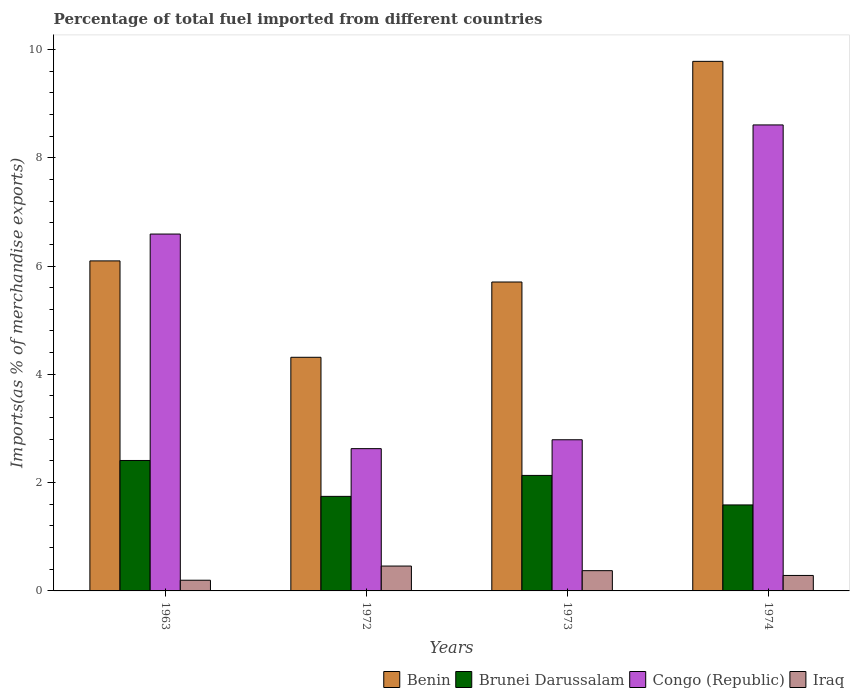How many bars are there on the 2nd tick from the left?
Ensure brevity in your answer.  4. What is the label of the 1st group of bars from the left?
Your response must be concise. 1963. What is the percentage of imports to different countries in Iraq in 1972?
Your response must be concise. 0.46. Across all years, what is the maximum percentage of imports to different countries in Brunei Darussalam?
Make the answer very short. 2.41. Across all years, what is the minimum percentage of imports to different countries in Iraq?
Give a very brief answer. 0.2. In which year was the percentage of imports to different countries in Iraq maximum?
Your answer should be compact. 1972. What is the total percentage of imports to different countries in Benin in the graph?
Give a very brief answer. 25.89. What is the difference between the percentage of imports to different countries in Iraq in 1963 and that in 1972?
Provide a succinct answer. -0.26. What is the difference between the percentage of imports to different countries in Iraq in 1963 and the percentage of imports to different countries in Benin in 1972?
Your response must be concise. -4.12. What is the average percentage of imports to different countries in Iraq per year?
Provide a succinct answer. 0.33. In the year 1963, what is the difference between the percentage of imports to different countries in Brunei Darussalam and percentage of imports to different countries in Iraq?
Give a very brief answer. 2.21. What is the ratio of the percentage of imports to different countries in Brunei Darussalam in 1963 to that in 1974?
Offer a very short reply. 1.52. What is the difference between the highest and the second highest percentage of imports to different countries in Brunei Darussalam?
Make the answer very short. 0.28. What is the difference between the highest and the lowest percentage of imports to different countries in Congo (Republic)?
Your answer should be very brief. 5.98. In how many years, is the percentage of imports to different countries in Iraq greater than the average percentage of imports to different countries in Iraq taken over all years?
Provide a succinct answer. 2. Is the sum of the percentage of imports to different countries in Congo (Republic) in 1963 and 1974 greater than the maximum percentage of imports to different countries in Brunei Darussalam across all years?
Ensure brevity in your answer.  Yes. What does the 3rd bar from the left in 1963 represents?
Your answer should be very brief. Congo (Republic). What does the 2nd bar from the right in 1963 represents?
Provide a succinct answer. Congo (Republic). How many bars are there?
Ensure brevity in your answer.  16. How many years are there in the graph?
Your answer should be compact. 4. Are the values on the major ticks of Y-axis written in scientific E-notation?
Provide a short and direct response. No. Does the graph contain any zero values?
Keep it short and to the point. No. Where does the legend appear in the graph?
Your response must be concise. Bottom right. How are the legend labels stacked?
Provide a succinct answer. Horizontal. What is the title of the graph?
Provide a succinct answer. Percentage of total fuel imported from different countries. Does "Barbados" appear as one of the legend labels in the graph?
Provide a short and direct response. No. What is the label or title of the Y-axis?
Make the answer very short. Imports(as % of merchandise exports). What is the Imports(as % of merchandise exports) in Benin in 1963?
Provide a succinct answer. 6.09. What is the Imports(as % of merchandise exports) of Brunei Darussalam in 1963?
Give a very brief answer. 2.41. What is the Imports(as % of merchandise exports) of Congo (Republic) in 1963?
Keep it short and to the point. 6.59. What is the Imports(as % of merchandise exports) in Iraq in 1963?
Ensure brevity in your answer.  0.2. What is the Imports(as % of merchandise exports) in Benin in 1972?
Offer a terse response. 4.31. What is the Imports(as % of merchandise exports) in Brunei Darussalam in 1972?
Ensure brevity in your answer.  1.75. What is the Imports(as % of merchandise exports) of Congo (Republic) in 1972?
Keep it short and to the point. 2.63. What is the Imports(as % of merchandise exports) in Iraq in 1972?
Your answer should be very brief. 0.46. What is the Imports(as % of merchandise exports) of Benin in 1973?
Your answer should be very brief. 5.7. What is the Imports(as % of merchandise exports) of Brunei Darussalam in 1973?
Your answer should be very brief. 2.13. What is the Imports(as % of merchandise exports) in Congo (Republic) in 1973?
Make the answer very short. 2.79. What is the Imports(as % of merchandise exports) in Iraq in 1973?
Offer a terse response. 0.37. What is the Imports(as % of merchandise exports) of Benin in 1974?
Give a very brief answer. 9.78. What is the Imports(as % of merchandise exports) of Brunei Darussalam in 1974?
Offer a terse response. 1.59. What is the Imports(as % of merchandise exports) of Congo (Republic) in 1974?
Your response must be concise. 8.61. What is the Imports(as % of merchandise exports) of Iraq in 1974?
Your answer should be very brief. 0.29. Across all years, what is the maximum Imports(as % of merchandise exports) of Benin?
Your answer should be compact. 9.78. Across all years, what is the maximum Imports(as % of merchandise exports) in Brunei Darussalam?
Your response must be concise. 2.41. Across all years, what is the maximum Imports(as % of merchandise exports) of Congo (Republic)?
Your answer should be compact. 8.61. Across all years, what is the maximum Imports(as % of merchandise exports) in Iraq?
Give a very brief answer. 0.46. Across all years, what is the minimum Imports(as % of merchandise exports) of Benin?
Your answer should be compact. 4.31. Across all years, what is the minimum Imports(as % of merchandise exports) of Brunei Darussalam?
Offer a terse response. 1.59. Across all years, what is the minimum Imports(as % of merchandise exports) in Congo (Republic)?
Your response must be concise. 2.63. Across all years, what is the minimum Imports(as % of merchandise exports) of Iraq?
Keep it short and to the point. 0.2. What is the total Imports(as % of merchandise exports) in Benin in the graph?
Your answer should be very brief. 25.89. What is the total Imports(as % of merchandise exports) of Brunei Darussalam in the graph?
Keep it short and to the point. 7.88. What is the total Imports(as % of merchandise exports) in Congo (Republic) in the graph?
Your response must be concise. 20.61. What is the total Imports(as % of merchandise exports) of Iraq in the graph?
Give a very brief answer. 1.32. What is the difference between the Imports(as % of merchandise exports) of Benin in 1963 and that in 1972?
Provide a succinct answer. 1.78. What is the difference between the Imports(as % of merchandise exports) in Brunei Darussalam in 1963 and that in 1972?
Give a very brief answer. 0.66. What is the difference between the Imports(as % of merchandise exports) in Congo (Republic) in 1963 and that in 1972?
Your response must be concise. 3.96. What is the difference between the Imports(as % of merchandise exports) in Iraq in 1963 and that in 1972?
Your response must be concise. -0.26. What is the difference between the Imports(as % of merchandise exports) in Benin in 1963 and that in 1973?
Ensure brevity in your answer.  0.39. What is the difference between the Imports(as % of merchandise exports) in Brunei Darussalam in 1963 and that in 1973?
Your response must be concise. 0.28. What is the difference between the Imports(as % of merchandise exports) in Congo (Republic) in 1963 and that in 1973?
Offer a very short reply. 3.8. What is the difference between the Imports(as % of merchandise exports) in Iraq in 1963 and that in 1973?
Keep it short and to the point. -0.18. What is the difference between the Imports(as % of merchandise exports) in Benin in 1963 and that in 1974?
Offer a terse response. -3.68. What is the difference between the Imports(as % of merchandise exports) of Brunei Darussalam in 1963 and that in 1974?
Provide a short and direct response. 0.82. What is the difference between the Imports(as % of merchandise exports) in Congo (Republic) in 1963 and that in 1974?
Your response must be concise. -2.02. What is the difference between the Imports(as % of merchandise exports) in Iraq in 1963 and that in 1974?
Make the answer very short. -0.09. What is the difference between the Imports(as % of merchandise exports) in Benin in 1972 and that in 1973?
Ensure brevity in your answer.  -1.39. What is the difference between the Imports(as % of merchandise exports) of Brunei Darussalam in 1972 and that in 1973?
Keep it short and to the point. -0.39. What is the difference between the Imports(as % of merchandise exports) in Congo (Republic) in 1972 and that in 1973?
Provide a short and direct response. -0.16. What is the difference between the Imports(as % of merchandise exports) of Iraq in 1972 and that in 1973?
Your answer should be very brief. 0.09. What is the difference between the Imports(as % of merchandise exports) of Benin in 1972 and that in 1974?
Provide a short and direct response. -5.46. What is the difference between the Imports(as % of merchandise exports) of Brunei Darussalam in 1972 and that in 1974?
Offer a terse response. 0.16. What is the difference between the Imports(as % of merchandise exports) of Congo (Republic) in 1972 and that in 1974?
Provide a succinct answer. -5.98. What is the difference between the Imports(as % of merchandise exports) of Iraq in 1972 and that in 1974?
Make the answer very short. 0.17. What is the difference between the Imports(as % of merchandise exports) of Benin in 1973 and that in 1974?
Your response must be concise. -4.07. What is the difference between the Imports(as % of merchandise exports) of Brunei Darussalam in 1973 and that in 1974?
Provide a succinct answer. 0.55. What is the difference between the Imports(as % of merchandise exports) in Congo (Republic) in 1973 and that in 1974?
Give a very brief answer. -5.81. What is the difference between the Imports(as % of merchandise exports) in Iraq in 1973 and that in 1974?
Offer a very short reply. 0.09. What is the difference between the Imports(as % of merchandise exports) of Benin in 1963 and the Imports(as % of merchandise exports) of Brunei Darussalam in 1972?
Make the answer very short. 4.35. What is the difference between the Imports(as % of merchandise exports) of Benin in 1963 and the Imports(as % of merchandise exports) of Congo (Republic) in 1972?
Provide a succinct answer. 3.47. What is the difference between the Imports(as % of merchandise exports) in Benin in 1963 and the Imports(as % of merchandise exports) in Iraq in 1972?
Ensure brevity in your answer.  5.63. What is the difference between the Imports(as % of merchandise exports) in Brunei Darussalam in 1963 and the Imports(as % of merchandise exports) in Congo (Republic) in 1972?
Offer a terse response. -0.22. What is the difference between the Imports(as % of merchandise exports) of Brunei Darussalam in 1963 and the Imports(as % of merchandise exports) of Iraq in 1972?
Provide a succinct answer. 1.95. What is the difference between the Imports(as % of merchandise exports) in Congo (Republic) in 1963 and the Imports(as % of merchandise exports) in Iraq in 1972?
Give a very brief answer. 6.13. What is the difference between the Imports(as % of merchandise exports) in Benin in 1963 and the Imports(as % of merchandise exports) in Brunei Darussalam in 1973?
Offer a terse response. 3.96. What is the difference between the Imports(as % of merchandise exports) in Benin in 1963 and the Imports(as % of merchandise exports) in Congo (Republic) in 1973?
Keep it short and to the point. 3.3. What is the difference between the Imports(as % of merchandise exports) in Benin in 1963 and the Imports(as % of merchandise exports) in Iraq in 1973?
Give a very brief answer. 5.72. What is the difference between the Imports(as % of merchandise exports) of Brunei Darussalam in 1963 and the Imports(as % of merchandise exports) of Congo (Republic) in 1973?
Your answer should be very brief. -0.38. What is the difference between the Imports(as % of merchandise exports) of Brunei Darussalam in 1963 and the Imports(as % of merchandise exports) of Iraq in 1973?
Your answer should be very brief. 2.03. What is the difference between the Imports(as % of merchandise exports) of Congo (Republic) in 1963 and the Imports(as % of merchandise exports) of Iraq in 1973?
Your answer should be very brief. 6.22. What is the difference between the Imports(as % of merchandise exports) in Benin in 1963 and the Imports(as % of merchandise exports) in Brunei Darussalam in 1974?
Give a very brief answer. 4.51. What is the difference between the Imports(as % of merchandise exports) of Benin in 1963 and the Imports(as % of merchandise exports) of Congo (Republic) in 1974?
Ensure brevity in your answer.  -2.51. What is the difference between the Imports(as % of merchandise exports) in Benin in 1963 and the Imports(as % of merchandise exports) in Iraq in 1974?
Give a very brief answer. 5.81. What is the difference between the Imports(as % of merchandise exports) in Brunei Darussalam in 1963 and the Imports(as % of merchandise exports) in Congo (Republic) in 1974?
Your answer should be compact. -6.2. What is the difference between the Imports(as % of merchandise exports) of Brunei Darussalam in 1963 and the Imports(as % of merchandise exports) of Iraq in 1974?
Offer a terse response. 2.12. What is the difference between the Imports(as % of merchandise exports) in Congo (Republic) in 1963 and the Imports(as % of merchandise exports) in Iraq in 1974?
Make the answer very short. 6.3. What is the difference between the Imports(as % of merchandise exports) in Benin in 1972 and the Imports(as % of merchandise exports) in Brunei Darussalam in 1973?
Provide a short and direct response. 2.18. What is the difference between the Imports(as % of merchandise exports) in Benin in 1972 and the Imports(as % of merchandise exports) in Congo (Republic) in 1973?
Ensure brevity in your answer.  1.52. What is the difference between the Imports(as % of merchandise exports) of Benin in 1972 and the Imports(as % of merchandise exports) of Iraq in 1973?
Offer a terse response. 3.94. What is the difference between the Imports(as % of merchandise exports) of Brunei Darussalam in 1972 and the Imports(as % of merchandise exports) of Congo (Republic) in 1973?
Give a very brief answer. -1.05. What is the difference between the Imports(as % of merchandise exports) of Brunei Darussalam in 1972 and the Imports(as % of merchandise exports) of Iraq in 1973?
Offer a very short reply. 1.37. What is the difference between the Imports(as % of merchandise exports) in Congo (Republic) in 1972 and the Imports(as % of merchandise exports) in Iraq in 1973?
Provide a short and direct response. 2.25. What is the difference between the Imports(as % of merchandise exports) of Benin in 1972 and the Imports(as % of merchandise exports) of Brunei Darussalam in 1974?
Keep it short and to the point. 2.73. What is the difference between the Imports(as % of merchandise exports) in Benin in 1972 and the Imports(as % of merchandise exports) in Congo (Republic) in 1974?
Your answer should be very brief. -4.29. What is the difference between the Imports(as % of merchandise exports) of Benin in 1972 and the Imports(as % of merchandise exports) of Iraq in 1974?
Provide a short and direct response. 4.03. What is the difference between the Imports(as % of merchandise exports) in Brunei Darussalam in 1972 and the Imports(as % of merchandise exports) in Congo (Republic) in 1974?
Offer a very short reply. -6.86. What is the difference between the Imports(as % of merchandise exports) in Brunei Darussalam in 1972 and the Imports(as % of merchandise exports) in Iraq in 1974?
Make the answer very short. 1.46. What is the difference between the Imports(as % of merchandise exports) of Congo (Republic) in 1972 and the Imports(as % of merchandise exports) of Iraq in 1974?
Give a very brief answer. 2.34. What is the difference between the Imports(as % of merchandise exports) of Benin in 1973 and the Imports(as % of merchandise exports) of Brunei Darussalam in 1974?
Offer a terse response. 4.12. What is the difference between the Imports(as % of merchandise exports) in Benin in 1973 and the Imports(as % of merchandise exports) in Congo (Republic) in 1974?
Offer a very short reply. -2.9. What is the difference between the Imports(as % of merchandise exports) of Benin in 1973 and the Imports(as % of merchandise exports) of Iraq in 1974?
Give a very brief answer. 5.42. What is the difference between the Imports(as % of merchandise exports) in Brunei Darussalam in 1973 and the Imports(as % of merchandise exports) in Congo (Republic) in 1974?
Ensure brevity in your answer.  -6.47. What is the difference between the Imports(as % of merchandise exports) in Brunei Darussalam in 1973 and the Imports(as % of merchandise exports) in Iraq in 1974?
Ensure brevity in your answer.  1.85. What is the difference between the Imports(as % of merchandise exports) in Congo (Republic) in 1973 and the Imports(as % of merchandise exports) in Iraq in 1974?
Offer a terse response. 2.51. What is the average Imports(as % of merchandise exports) in Benin per year?
Ensure brevity in your answer.  6.47. What is the average Imports(as % of merchandise exports) in Brunei Darussalam per year?
Your answer should be very brief. 1.97. What is the average Imports(as % of merchandise exports) in Congo (Republic) per year?
Keep it short and to the point. 5.15. What is the average Imports(as % of merchandise exports) of Iraq per year?
Ensure brevity in your answer.  0.33. In the year 1963, what is the difference between the Imports(as % of merchandise exports) of Benin and Imports(as % of merchandise exports) of Brunei Darussalam?
Your response must be concise. 3.69. In the year 1963, what is the difference between the Imports(as % of merchandise exports) in Benin and Imports(as % of merchandise exports) in Congo (Republic)?
Make the answer very short. -0.5. In the year 1963, what is the difference between the Imports(as % of merchandise exports) of Benin and Imports(as % of merchandise exports) of Iraq?
Make the answer very short. 5.9. In the year 1963, what is the difference between the Imports(as % of merchandise exports) in Brunei Darussalam and Imports(as % of merchandise exports) in Congo (Republic)?
Offer a terse response. -4.18. In the year 1963, what is the difference between the Imports(as % of merchandise exports) in Brunei Darussalam and Imports(as % of merchandise exports) in Iraq?
Provide a short and direct response. 2.21. In the year 1963, what is the difference between the Imports(as % of merchandise exports) in Congo (Republic) and Imports(as % of merchandise exports) in Iraq?
Provide a short and direct response. 6.39. In the year 1972, what is the difference between the Imports(as % of merchandise exports) in Benin and Imports(as % of merchandise exports) in Brunei Darussalam?
Ensure brevity in your answer.  2.57. In the year 1972, what is the difference between the Imports(as % of merchandise exports) of Benin and Imports(as % of merchandise exports) of Congo (Republic)?
Your answer should be compact. 1.69. In the year 1972, what is the difference between the Imports(as % of merchandise exports) in Benin and Imports(as % of merchandise exports) in Iraq?
Your response must be concise. 3.85. In the year 1972, what is the difference between the Imports(as % of merchandise exports) in Brunei Darussalam and Imports(as % of merchandise exports) in Congo (Republic)?
Offer a terse response. -0.88. In the year 1972, what is the difference between the Imports(as % of merchandise exports) of Brunei Darussalam and Imports(as % of merchandise exports) of Iraq?
Provide a short and direct response. 1.29. In the year 1972, what is the difference between the Imports(as % of merchandise exports) in Congo (Republic) and Imports(as % of merchandise exports) in Iraq?
Give a very brief answer. 2.17. In the year 1973, what is the difference between the Imports(as % of merchandise exports) of Benin and Imports(as % of merchandise exports) of Brunei Darussalam?
Your answer should be very brief. 3.57. In the year 1973, what is the difference between the Imports(as % of merchandise exports) in Benin and Imports(as % of merchandise exports) in Congo (Republic)?
Keep it short and to the point. 2.91. In the year 1973, what is the difference between the Imports(as % of merchandise exports) in Benin and Imports(as % of merchandise exports) in Iraq?
Your answer should be very brief. 5.33. In the year 1973, what is the difference between the Imports(as % of merchandise exports) in Brunei Darussalam and Imports(as % of merchandise exports) in Congo (Republic)?
Give a very brief answer. -0.66. In the year 1973, what is the difference between the Imports(as % of merchandise exports) in Brunei Darussalam and Imports(as % of merchandise exports) in Iraq?
Keep it short and to the point. 1.76. In the year 1973, what is the difference between the Imports(as % of merchandise exports) in Congo (Republic) and Imports(as % of merchandise exports) in Iraq?
Offer a terse response. 2.42. In the year 1974, what is the difference between the Imports(as % of merchandise exports) of Benin and Imports(as % of merchandise exports) of Brunei Darussalam?
Offer a very short reply. 8.19. In the year 1974, what is the difference between the Imports(as % of merchandise exports) of Benin and Imports(as % of merchandise exports) of Congo (Republic)?
Give a very brief answer. 1.17. In the year 1974, what is the difference between the Imports(as % of merchandise exports) of Benin and Imports(as % of merchandise exports) of Iraq?
Make the answer very short. 9.49. In the year 1974, what is the difference between the Imports(as % of merchandise exports) of Brunei Darussalam and Imports(as % of merchandise exports) of Congo (Republic)?
Offer a very short reply. -7.02. In the year 1974, what is the difference between the Imports(as % of merchandise exports) of Brunei Darussalam and Imports(as % of merchandise exports) of Iraq?
Give a very brief answer. 1.3. In the year 1974, what is the difference between the Imports(as % of merchandise exports) of Congo (Republic) and Imports(as % of merchandise exports) of Iraq?
Your response must be concise. 8.32. What is the ratio of the Imports(as % of merchandise exports) of Benin in 1963 to that in 1972?
Offer a terse response. 1.41. What is the ratio of the Imports(as % of merchandise exports) in Brunei Darussalam in 1963 to that in 1972?
Keep it short and to the point. 1.38. What is the ratio of the Imports(as % of merchandise exports) of Congo (Republic) in 1963 to that in 1972?
Your answer should be very brief. 2.51. What is the ratio of the Imports(as % of merchandise exports) of Iraq in 1963 to that in 1972?
Offer a terse response. 0.43. What is the ratio of the Imports(as % of merchandise exports) in Benin in 1963 to that in 1973?
Make the answer very short. 1.07. What is the ratio of the Imports(as % of merchandise exports) of Brunei Darussalam in 1963 to that in 1973?
Make the answer very short. 1.13. What is the ratio of the Imports(as % of merchandise exports) of Congo (Republic) in 1963 to that in 1973?
Make the answer very short. 2.36. What is the ratio of the Imports(as % of merchandise exports) of Iraq in 1963 to that in 1973?
Make the answer very short. 0.53. What is the ratio of the Imports(as % of merchandise exports) in Benin in 1963 to that in 1974?
Ensure brevity in your answer.  0.62. What is the ratio of the Imports(as % of merchandise exports) of Brunei Darussalam in 1963 to that in 1974?
Provide a succinct answer. 1.52. What is the ratio of the Imports(as % of merchandise exports) of Congo (Republic) in 1963 to that in 1974?
Your answer should be very brief. 0.77. What is the ratio of the Imports(as % of merchandise exports) of Iraq in 1963 to that in 1974?
Make the answer very short. 0.69. What is the ratio of the Imports(as % of merchandise exports) in Benin in 1972 to that in 1973?
Ensure brevity in your answer.  0.76. What is the ratio of the Imports(as % of merchandise exports) of Brunei Darussalam in 1972 to that in 1973?
Your answer should be compact. 0.82. What is the ratio of the Imports(as % of merchandise exports) in Congo (Republic) in 1972 to that in 1973?
Offer a terse response. 0.94. What is the ratio of the Imports(as % of merchandise exports) of Iraq in 1972 to that in 1973?
Your answer should be very brief. 1.23. What is the ratio of the Imports(as % of merchandise exports) in Benin in 1972 to that in 1974?
Offer a terse response. 0.44. What is the ratio of the Imports(as % of merchandise exports) in Brunei Darussalam in 1972 to that in 1974?
Make the answer very short. 1.1. What is the ratio of the Imports(as % of merchandise exports) in Congo (Republic) in 1972 to that in 1974?
Your response must be concise. 0.31. What is the ratio of the Imports(as % of merchandise exports) of Iraq in 1972 to that in 1974?
Give a very brief answer. 1.61. What is the ratio of the Imports(as % of merchandise exports) in Benin in 1973 to that in 1974?
Offer a very short reply. 0.58. What is the ratio of the Imports(as % of merchandise exports) of Brunei Darussalam in 1973 to that in 1974?
Ensure brevity in your answer.  1.34. What is the ratio of the Imports(as % of merchandise exports) in Congo (Republic) in 1973 to that in 1974?
Your response must be concise. 0.32. What is the ratio of the Imports(as % of merchandise exports) of Iraq in 1973 to that in 1974?
Make the answer very short. 1.31. What is the difference between the highest and the second highest Imports(as % of merchandise exports) in Benin?
Give a very brief answer. 3.68. What is the difference between the highest and the second highest Imports(as % of merchandise exports) in Brunei Darussalam?
Make the answer very short. 0.28. What is the difference between the highest and the second highest Imports(as % of merchandise exports) in Congo (Republic)?
Your answer should be very brief. 2.02. What is the difference between the highest and the second highest Imports(as % of merchandise exports) in Iraq?
Your answer should be compact. 0.09. What is the difference between the highest and the lowest Imports(as % of merchandise exports) of Benin?
Give a very brief answer. 5.46. What is the difference between the highest and the lowest Imports(as % of merchandise exports) of Brunei Darussalam?
Your response must be concise. 0.82. What is the difference between the highest and the lowest Imports(as % of merchandise exports) of Congo (Republic)?
Provide a succinct answer. 5.98. What is the difference between the highest and the lowest Imports(as % of merchandise exports) in Iraq?
Keep it short and to the point. 0.26. 